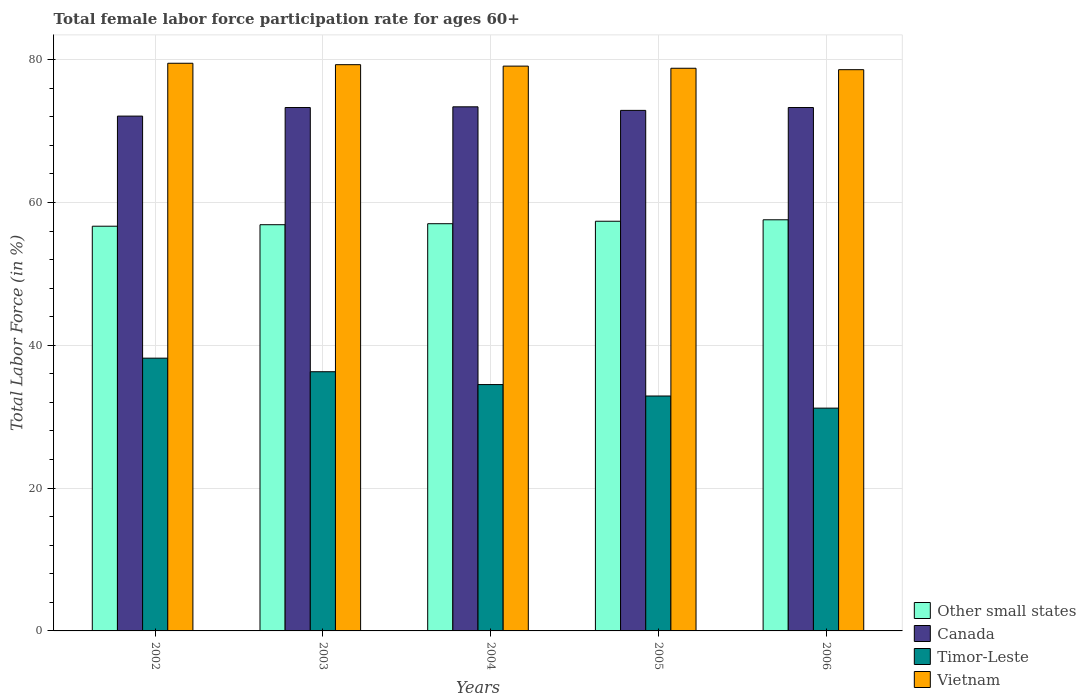How many groups of bars are there?
Your answer should be very brief. 5. Are the number of bars on each tick of the X-axis equal?
Offer a terse response. Yes. What is the female labor force participation rate in Timor-Leste in 2006?
Your answer should be very brief. 31.2. Across all years, what is the maximum female labor force participation rate in Canada?
Your answer should be compact. 73.4. Across all years, what is the minimum female labor force participation rate in Other small states?
Give a very brief answer. 56.68. In which year was the female labor force participation rate in Other small states minimum?
Provide a succinct answer. 2002. What is the total female labor force participation rate in Other small states in the graph?
Your response must be concise. 285.55. What is the difference between the female labor force participation rate in Timor-Leste in 2003 and that in 2006?
Keep it short and to the point. 5.1. What is the difference between the female labor force participation rate in Other small states in 2006 and the female labor force participation rate in Vietnam in 2004?
Provide a succinct answer. -21.52. What is the average female labor force participation rate in Vietnam per year?
Give a very brief answer. 79.06. In the year 2006, what is the difference between the female labor force participation rate in Vietnam and female labor force participation rate in Canada?
Provide a short and direct response. 5.3. In how many years, is the female labor force participation rate in Canada greater than 36 %?
Ensure brevity in your answer.  5. What is the ratio of the female labor force participation rate in Other small states in 2003 to that in 2005?
Provide a succinct answer. 0.99. Is the female labor force participation rate in Canada in 2005 less than that in 2006?
Offer a terse response. Yes. What is the difference between the highest and the second highest female labor force participation rate in Other small states?
Ensure brevity in your answer.  0.2. What is the difference between the highest and the lowest female labor force participation rate in Vietnam?
Provide a short and direct response. 0.9. In how many years, is the female labor force participation rate in Vietnam greater than the average female labor force participation rate in Vietnam taken over all years?
Ensure brevity in your answer.  3. Is it the case that in every year, the sum of the female labor force participation rate in Other small states and female labor force participation rate in Timor-Leste is greater than the sum of female labor force participation rate in Canada and female labor force participation rate in Vietnam?
Give a very brief answer. No. What does the 4th bar from the left in 2005 represents?
Keep it short and to the point. Vietnam. What does the 2nd bar from the right in 2006 represents?
Offer a terse response. Timor-Leste. Is it the case that in every year, the sum of the female labor force participation rate in Timor-Leste and female labor force participation rate in Vietnam is greater than the female labor force participation rate in Canada?
Your answer should be very brief. Yes. Are all the bars in the graph horizontal?
Your response must be concise. No. Does the graph contain any zero values?
Your response must be concise. No. How many legend labels are there?
Ensure brevity in your answer.  4. How are the legend labels stacked?
Make the answer very short. Vertical. What is the title of the graph?
Offer a very short reply. Total female labor force participation rate for ages 60+. Does "Oman" appear as one of the legend labels in the graph?
Your answer should be very brief. No. What is the label or title of the X-axis?
Offer a very short reply. Years. What is the Total Labor Force (in %) of Other small states in 2002?
Ensure brevity in your answer.  56.68. What is the Total Labor Force (in %) in Canada in 2002?
Offer a terse response. 72.1. What is the Total Labor Force (in %) of Timor-Leste in 2002?
Keep it short and to the point. 38.2. What is the Total Labor Force (in %) in Vietnam in 2002?
Your answer should be very brief. 79.5. What is the Total Labor Force (in %) in Other small states in 2003?
Offer a terse response. 56.89. What is the Total Labor Force (in %) of Canada in 2003?
Give a very brief answer. 73.3. What is the Total Labor Force (in %) of Timor-Leste in 2003?
Offer a terse response. 36.3. What is the Total Labor Force (in %) in Vietnam in 2003?
Provide a short and direct response. 79.3. What is the Total Labor Force (in %) in Other small states in 2004?
Your answer should be very brief. 57.03. What is the Total Labor Force (in %) in Canada in 2004?
Offer a terse response. 73.4. What is the Total Labor Force (in %) in Timor-Leste in 2004?
Offer a very short reply. 34.5. What is the Total Labor Force (in %) in Vietnam in 2004?
Make the answer very short. 79.1. What is the Total Labor Force (in %) of Other small states in 2005?
Provide a short and direct response. 57.37. What is the Total Labor Force (in %) of Canada in 2005?
Provide a succinct answer. 72.9. What is the Total Labor Force (in %) of Timor-Leste in 2005?
Offer a terse response. 32.9. What is the Total Labor Force (in %) in Vietnam in 2005?
Keep it short and to the point. 78.8. What is the Total Labor Force (in %) of Other small states in 2006?
Your response must be concise. 57.58. What is the Total Labor Force (in %) of Canada in 2006?
Offer a very short reply. 73.3. What is the Total Labor Force (in %) in Timor-Leste in 2006?
Offer a very short reply. 31.2. What is the Total Labor Force (in %) in Vietnam in 2006?
Provide a succinct answer. 78.6. Across all years, what is the maximum Total Labor Force (in %) in Other small states?
Offer a terse response. 57.58. Across all years, what is the maximum Total Labor Force (in %) in Canada?
Offer a very short reply. 73.4. Across all years, what is the maximum Total Labor Force (in %) of Timor-Leste?
Your answer should be compact. 38.2. Across all years, what is the maximum Total Labor Force (in %) of Vietnam?
Give a very brief answer. 79.5. Across all years, what is the minimum Total Labor Force (in %) in Other small states?
Your response must be concise. 56.68. Across all years, what is the minimum Total Labor Force (in %) in Canada?
Your answer should be compact. 72.1. Across all years, what is the minimum Total Labor Force (in %) in Timor-Leste?
Make the answer very short. 31.2. Across all years, what is the minimum Total Labor Force (in %) of Vietnam?
Offer a terse response. 78.6. What is the total Total Labor Force (in %) in Other small states in the graph?
Offer a terse response. 285.55. What is the total Total Labor Force (in %) of Canada in the graph?
Give a very brief answer. 365. What is the total Total Labor Force (in %) of Timor-Leste in the graph?
Keep it short and to the point. 173.1. What is the total Total Labor Force (in %) of Vietnam in the graph?
Give a very brief answer. 395.3. What is the difference between the Total Labor Force (in %) of Other small states in 2002 and that in 2003?
Give a very brief answer. -0.21. What is the difference between the Total Labor Force (in %) in Timor-Leste in 2002 and that in 2003?
Offer a very short reply. 1.9. What is the difference between the Total Labor Force (in %) of Vietnam in 2002 and that in 2003?
Your response must be concise. 0.2. What is the difference between the Total Labor Force (in %) in Other small states in 2002 and that in 2004?
Provide a succinct answer. -0.35. What is the difference between the Total Labor Force (in %) in Canada in 2002 and that in 2004?
Keep it short and to the point. -1.3. What is the difference between the Total Labor Force (in %) in Other small states in 2002 and that in 2005?
Provide a short and direct response. -0.69. What is the difference between the Total Labor Force (in %) in Other small states in 2002 and that in 2006?
Keep it short and to the point. -0.9. What is the difference between the Total Labor Force (in %) in Other small states in 2003 and that in 2004?
Offer a terse response. -0.14. What is the difference between the Total Labor Force (in %) in Canada in 2003 and that in 2004?
Your answer should be very brief. -0.1. What is the difference between the Total Labor Force (in %) of Timor-Leste in 2003 and that in 2004?
Offer a very short reply. 1.8. What is the difference between the Total Labor Force (in %) of Other small states in 2003 and that in 2005?
Your answer should be compact. -0.49. What is the difference between the Total Labor Force (in %) in Canada in 2003 and that in 2005?
Provide a succinct answer. 0.4. What is the difference between the Total Labor Force (in %) in Vietnam in 2003 and that in 2005?
Ensure brevity in your answer.  0.5. What is the difference between the Total Labor Force (in %) in Other small states in 2003 and that in 2006?
Ensure brevity in your answer.  -0.69. What is the difference between the Total Labor Force (in %) of Canada in 2003 and that in 2006?
Give a very brief answer. 0. What is the difference between the Total Labor Force (in %) of Timor-Leste in 2003 and that in 2006?
Your answer should be compact. 5.1. What is the difference between the Total Labor Force (in %) of Vietnam in 2003 and that in 2006?
Keep it short and to the point. 0.7. What is the difference between the Total Labor Force (in %) in Other small states in 2004 and that in 2005?
Offer a terse response. -0.35. What is the difference between the Total Labor Force (in %) in Canada in 2004 and that in 2005?
Ensure brevity in your answer.  0.5. What is the difference between the Total Labor Force (in %) in Timor-Leste in 2004 and that in 2005?
Your answer should be compact. 1.6. What is the difference between the Total Labor Force (in %) in Other small states in 2004 and that in 2006?
Offer a very short reply. -0.55. What is the difference between the Total Labor Force (in %) in Canada in 2004 and that in 2006?
Provide a succinct answer. 0.1. What is the difference between the Total Labor Force (in %) in Other small states in 2005 and that in 2006?
Provide a short and direct response. -0.2. What is the difference between the Total Labor Force (in %) of Canada in 2005 and that in 2006?
Your answer should be very brief. -0.4. What is the difference between the Total Labor Force (in %) in Timor-Leste in 2005 and that in 2006?
Offer a terse response. 1.7. What is the difference between the Total Labor Force (in %) of Other small states in 2002 and the Total Labor Force (in %) of Canada in 2003?
Offer a terse response. -16.62. What is the difference between the Total Labor Force (in %) in Other small states in 2002 and the Total Labor Force (in %) in Timor-Leste in 2003?
Provide a succinct answer. 20.38. What is the difference between the Total Labor Force (in %) in Other small states in 2002 and the Total Labor Force (in %) in Vietnam in 2003?
Offer a very short reply. -22.62. What is the difference between the Total Labor Force (in %) in Canada in 2002 and the Total Labor Force (in %) in Timor-Leste in 2003?
Your response must be concise. 35.8. What is the difference between the Total Labor Force (in %) of Canada in 2002 and the Total Labor Force (in %) of Vietnam in 2003?
Offer a terse response. -7.2. What is the difference between the Total Labor Force (in %) in Timor-Leste in 2002 and the Total Labor Force (in %) in Vietnam in 2003?
Give a very brief answer. -41.1. What is the difference between the Total Labor Force (in %) of Other small states in 2002 and the Total Labor Force (in %) of Canada in 2004?
Give a very brief answer. -16.72. What is the difference between the Total Labor Force (in %) of Other small states in 2002 and the Total Labor Force (in %) of Timor-Leste in 2004?
Your response must be concise. 22.18. What is the difference between the Total Labor Force (in %) in Other small states in 2002 and the Total Labor Force (in %) in Vietnam in 2004?
Your response must be concise. -22.42. What is the difference between the Total Labor Force (in %) in Canada in 2002 and the Total Labor Force (in %) in Timor-Leste in 2004?
Your response must be concise. 37.6. What is the difference between the Total Labor Force (in %) in Canada in 2002 and the Total Labor Force (in %) in Vietnam in 2004?
Keep it short and to the point. -7. What is the difference between the Total Labor Force (in %) of Timor-Leste in 2002 and the Total Labor Force (in %) of Vietnam in 2004?
Keep it short and to the point. -40.9. What is the difference between the Total Labor Force (in %) of Other small states in 2002 and the Total Labor Force (in %) of Canada in 2005?
Your answer should be compact. -16.22. What is the difference between the Total Labor Force (in %) in Other small states in 2002 and the Total Labor Force (in %) in Timor-Leste in 2005?
Give a very brief answer. 23.78. What is the difference between the Total Labor Force (in %) of Other small states in 2002 and the Total Labor Force (in %) of Vietnam in 2005?
Give a very brief answer. -22.12. What is the difference between the Total Labor Force (in %) in Canada in 2002 and the Total Labor Force (in %) in Timor-Leste in 2005?
Make the answer very short. 39.2. What is the difference between the Total Labor Force (in %) of Canada in 2002 and the Total Labor Force (in %) of Vietnam in 2005?
Give a very brief answer. -6.7. What is the difference between the Total Labor Force (in %) of Timor-Leste in 2002 and the Total Labor Force (in %) of Vietnam in 2005?
Provide a succinct answer. -40.6. What is the difference between the Total Labor Force (in %) in Other small states in 2002 and the Total Labor Force (in %) in Canada in 2006?
Keep it short and to the point. -16.62. What is the difference between the Total Labor Force (in %) in Other small states in 2002 and the Total Labor Force (in %) in Timor-Leste in 2006?
Give a very brief answer. 25.48. What is the difference between the Total Labor Force (in %) of Other small states in 2002 and the Total Labor Force (in %) of Vietnam in 2006?
Provide a succinct answer. -21.92. What is the difference between the Total Labor Force (in %) in Canada in 2002 and the Total Labor Force (in %) in Timor-Leste in 2006?
Make the answer very short. 40.9. What is the difference between the Total Labor Force (in %) of Timor-Leste in 2002 and the Total Labor Force (in %) of Vietnam in 2006?
Keep it short and to the point. -40.4. What is the difference between the Total Labor Force (in %) in Other small states in 2003 and the Total Labor Force (in %) in Canada in 2004?
Keep it short and to the point. -16.51. What is the difference between the Total Labor Force (in %) in Other small states in 2003 and the Total Labor Force (in %) in Timor-Leste in 2004?
Give a very brief answer. 22.39. What is the difference between the Total Labor Force (in %) in Other small states in 2003 and the Total Labor Force (in %) in Vietnam in 2004?
Your response must be concise. -22.21. What is the difference between the Total Labor Force (in %) in Canada in 2003 and the Total Labor Force (in %) in Timor-Leste in 2004?
Your answer should be very brief. 38.8. What is the difference between the Total Labor Force (in %) of Timor-Leste in 2003 and the Total Labor Force (in %) of Vietnam in 2004?
Ensure brevity in your answer.  -42.8. What is the difference between the Total Labor Force (in %) in Other small states in 2003 and the Total Labor Force (in %) in Canada in 2005?
Your answer should be compact. -16.01. What is the difference between the Total Labor Force (in %) in Other small states in 2003 and the Total Labor Force (in %) in Timor-Leste in 2005?
Give a very brief answer. 23.99. What is the difference between the Total Labor Force (in %) in Other small states in 2003 and the Total Labor Force (in %) in Vietnam in 2005?
Keep it short and to the point. -21.91. What is the difference between the Total Labor Force (in %) in Canada in 2003 and the Total Labor Force (in %) in Timor-Leste in 2005?
Your response must be concise. 40.4. What is the difference between the Total Labor Force (in %) of Canada in 2003 and the Total Labor Force (in %) of Vietnam in 2005?
Give a very brief answer. -5.5. What is the difference between the Total Labor Force (in %) in Timor-Leste in 2003 and the Total Labor Force (in %) in Vietnam in 2005?
Ensure brevity in your answer.  -42.5. What is the difference between the Total Labor Force (in %) in Other small states in 2003 and the Total Labor Force (in %) in Canada in 2006?
Provide a succinct answer. -16.41. What is the difference between the Total Labor Force (in %) of Other small states in 2003 and the Total Labor Force (in %) of Timor-Leste in 2006?
Ensure brevity in your answer.  25.69. What is the difference between the Total Labor Force (in %) of Other small states in 2003 and the Total Labor Force (in %) of Vietnam in 2006?
Your answer should be very brief. -21.71. What is the difference between the Total Labor Force (in %) of Canada in 2003 and the Total Labor Force (in %) of Timor-Leste in 2006?
Provide a succinct answer. 42.1. What is the difference between the Total Labor Force (in %) in Timor-Leste in 2003 and the Total Labor Force (in %) in Vietnam in 2006?
Offer a very short reply. -42.3. What is the difference between the Total Labor Force (in %) of Other small states in 2004 and the Total Labor Force (in %) of Canada in 2005?
Your answer should be very brief. -15.87. What is the difference between the Total Labor Force (in %) of Other small states in 2004 and the Total Labor Force (in %) of Timor-Leste in 2005?
Provide a short and direct response. 24.13. What is the difference between the Total Labor Force (in %) of Other small states in 2004 and the Total Labor Force (in %) of Vietnam in 2005?
Keep it short and to the point. -21.77. What is the difference between the Total Labor Force (in %) of Canada in 2004 and the Total Labor Force (in %) of Timor-Leste in 2005?
Keep it short and to the point. 40.5. What is the difference between the Total Labor Force (in %) in Timor-Leste in 2004 and the Total Labor Force (in %) in Vietnam in 2005?
Offer a very short reply. -44.3. What is the difference between the Total Labor Force (in %) of Other small states in 2004 and the Total Labor Force (in %) of Canada in 2006?
Make the answer very short. -16.27. What is the difference between the Total Labor Force (in %) in Other small states in 2004 and the Total Labor Force (in %) in Timor-Leste in 2006?
Provide a short and direct response. 25.83. What is the difference between the Total Labor Force (in %) in Other small states in 2004 and the Total Labor Force (in %) in Vietnam in 2006?
Give a very brief answer. -21.57. What is the difference between the Total Labor Force (in %) of Canada in 2004 and the Total Labor Force (in %) of Timor-Leste in 2006?
Give a very brief answer. 42.2. What is the difference between the Total Labor Force (in %) in Timor-Leste in 2004 and the Total Labor Force (in %) in Vietnam in 2006?
Make the answer very short. -44.1. What is the difference between the Total Labor Force (in %) of Other small states in 2005 and the Total Labor Force (in %) of Canada in 2006?
Your response must be concise. -15.93. What is the difference between the Total Labor Force (in %) in Other small states in 2005 and the Total Labor Force (in %) in Timor-Leste in 2006?
Provide a succinct answer. 26.17. What is the difference between the Total Labor Force (in %) of Other small states in 2005 and the Total Labor Force (in %) of Vietnam in 2006?
Provide a succinct answer. -21.23. What is the difference between the Total Labor Force (in %) of Canada in 2005 and the Total Labor Force (in %) of Timor-Leste in 2006?
Your response must be concise. 41.7. What is the difference between the Total Labor Force (in %) of Canada in 2005 and the Total Labor Force (in %) of Vietnam in 2006?
Keep it short and to the point. -5.7. What is the difference between the Total Labor Force (in %) in Timor-Leste in 2005 and the Total Labor Force (in %) in Vietnam in 2006?
Provide a succinct answer. -45.7. What is the average Total Labor Force (in %) in Other small states per year?
Offer a very short reply. 57.11. What is the average Total Labor Force (in %) of Canada per year?
Your answer should be compact. 73. What is the average Total Labor Force (in %) of Timor-Leste per year?
Your answer should be very brief. 34.62. What is the average Total Labor Force (in %) of Vietnam per year?
Keep it short and to the point. 79.06. In the year 2002, what is the difference between the Total Labor Force (in %) in Other small states and Total Labor Force (in %) in Canada?
Offer a terse response. -15.42. In the year 2002, what is the difference between the Total Labor Force (in %) in Other small states and Total Labor Force (in %) in Timor-Leste?
Offer a very short reply. 18.48. In the year 2002, what is the difference between the Total Labor Force (in %) in Other small states and Total Labor Force (in %) in Vietnam?
Give a very brief answer. -22.82. In the year 2002, what is the difference between the Total Labor Force (in %) in Canada and Total Labor Force (in %) in Timor-Leste?
Ensure brevity in your answer.  33.9. In the year 2002, what is the difference between the Total Labor Force (in %) of Timor-Leste and Total Labor Force (in %) of Vietnam?
Give a very brief answer. -41.3. In the year 2003, what is the difference between the Total Labor Force (in %) in Other small states and Total Labor Force (in %) in Canada?
Your answer should be compact. -16.41. In the year 2003, what is the difference between the Total Labor Force (in %) of Other small states and Total Labor Force (in %) of Timor-Leste?
Provide a succinct answer. 20.59. In the year 2003, what is the difference between the Total Labor Force (in %) of Other small states and Total Labor Force (in %) of Vietnam?
Ensure brevity in your answer.  -22.41. In the year 2003, what is the difference between the Total Labor Force (in %) in Timor-Leste and Total Labor Force (in %) in Vietnam?
Ensure brevity in your answer.  -43. In the year 2004, what is the difference between the Total Labor Force (in %) in Other small states and Total Labor Force (in %) in Canada?
Your response must be concise. -16.37. In the year 2004, what is the difference between the Total Labor Force (in %) of Other small states and Total Labor Force (in %) of Timor-Leste?
Ensure brevity in your answer.  22.53. In the year 2004, what is the difference between the Total Labor Force (in %) in Other small states and Total Labor Force (in %) in Vietnam?
Keep it short and to the point. -22.07. In the year 2004, what is the difference between the Total Labor Force (in %) of Canada and Total Labor Force (in %) of Timor-Leste?
Offer a very short reply. 38.9. In the year 2004, what is the difference between the Total Labor Force (in %) in Timor-Leste and Total Labor Force (in %) in Vietnam?
Your answer should be compact. -44.6. In the year 2005, what is the difference between the Total Labor Force (in %) in Other small states and Total Labor Force (in %) in Canada?
Offer a terse response. -15.53. In the year 2005, what is the difference between the Total Labor Force (in %) in Other small states and Total Labor Force (in %) in Timor-Leste?
Your answer should be compact. 24.47. In the year 2005, what is the difference between the Total Labor Force (in %) in Other small states and Total Labor Force (in %) in Vietnam?
Your answer should be compact. -21.43. In the year 2005, what is the difference between the Total Labor Force (in %) in Canada and Total Labor Force (in %) in Timor-Leste?
Provide a succinct answer. 40. In the year 2005, what is the difference between the Total Labor Force (in %) of Timor-Leste and Total Labor Force (in %) of Vietnam?
Offer a very short reply. -45.9. In the year 2006, what is the difference between the Total Labor Force (in %) of Other small states and Total Labor Force (in %) of Canada?
Offer a terse response. -15.72. In the year 2006, what is the difference between the Total Labor Force (in %) of Other small states and Total Labor Force (in %) of Timor-Leste?
Offer a terse response. 26.38. In the year 2006, what is the difference between the Total Labor Force (in %) of Other small states and Total Labor Force (in %) of Vietnam?
Give a very brief answer. -21.02. In the year 2006, what is the difference between the Total Labor Force (in %) in Canada and Total Labor Force (in %) in Timor-Leste?
Offer a terse response. 42.1. In the year 2006, what is the difference between the Total Labor Force (in %) of Canada and Total Labor Force (in %) of Vietnam?
Your answer should be very brief. -5.3. In the year 2006, what is the difference between the Total Labor Force (in %) of Timor-Leste and Total Labor Force (in %) of Vietnam?
Keep it short and to the point. -47.4. What is the ratio of the Total Labor Force (in %) of Canada in 2002 to that in 2003?
Give a very brief answer. 0.98. What is the ratio of the Total Labor Force (in %) of Timor-Leste in 2002 to that in 2003?
Ensure brevity in your answer.  1.05. What is the ratio of the Total Labor Force (in %) of Vietnam in 2002 to that in 2003?
Provide a short and direct response. 1. What is the ratio of the Total Labor Force (in %) in Canada in 2002 to that in 2004?
Your answer should be compact. 0.98. What is the ratio of the Total Labor Force (in %) in Timor-Leste in 2002 to that in 2004?
Offer a terse response. 1.11. What is the ratio of the Total Labor Force (in %) in Vietnam in 2002 to that in 2004?
Your response must be concise. 1.01. What is the ratio of the Total Labor Force (in %) of Other small states in 2002 to that in 2005?
Provide a succinct answer. 0.99. What is the ratio of the Total Labor Force (in %) in Timor-Leste in 2002 to that in 2005?
Your response must be concise. 1.16. What is the ratio of the Total Labor Force (in %) of Vietnam in 2002 to that in 2005?
Give a very brief answer. 1.01. What is the ratio of the Total Labor Force (in %) in Other small states in 2002 to that in 2006?
Offer a very short reply. 0.98. What is the ratio of the Total Labor Force (in %) in Canada in 2002 to that in 2006?
Your answer should be very brief. 0.98. What is the ratio of the Total Labor Force (in %) in Timor-Leste in 2002 to that in 2006?
Keep it short and to the point. 1.22. What is the ratio of the Total Labor Force (in %) in Vietnam in 2002 to that in 2006?
Offer a terse response. 1.01. What is the ratio of the Total Labor Force (in %) of Other small states in 2003 to that in 2004?
Keep it short and to the point. 1. What is the ratio of the Total Labor Force (in %) of Canada in 2003 to that in 2004?
Your answer should be compact. 1. What is the ratio of the Total Labor Force (in %) in Timor-Leste in 2003 to that in 2004?
Offer a very short reply. 1.05. What is the ratio of the Total Labor Force (in %) in Vietnam in 2003 to that in 2004?
Your answer should be very brief. 1. What is the ratio of the Total Labor Force (in %) in Canada in 2003 to that in 2005?
Provide a succinct answer. 1.01. What is the ratio of the Total Labor Force (in %) in Timor-Leste in 2003 to that in 2005?
Your response must be concise. 1.1. What is the ratio of the Total Labor Force (in %) in Vietnam in 2003 to that in 2005?
Provide a short and direct response. 1.01. What is the ratio of the Total Labor Force (in %) of Canada in 2003 to that in 2006?
Your answer should be compact. 1. What is the ratio of the Total Labor Force (in %) in Timor-Leste in 2003 to that in 2006?
Keep it short and to the point. 1.16. What is the ratio of the Total Labor Force (in %) in Vietnam in 2003 to that in 2006?
Provide a succinct answer. 1.01. What is the ratio of the Total Labor Force (in %) in Timor-Leste in 2004 to that in 2005?
Offer a very short reply. 1.05. What is the ratio of the Total Labor Force (in %) in Canada in 2004 to that in 2006?
Your response must be concise. 1. What is the ratio of the Total Labor Force (in %) in Timor-Leste in 2004 to that in 2006?
Give a very brief answer. 1.11. What is the ratio of the Total Labor Force (in %) in Vietnam in 2004 to that in 2006?
Your response must be concise. 1.01. What is the ratio of the Total Labor Force (in %) of Timor-Leste in 2005 to that in 2006?
Provide a short and direct response. 1.05. What is the ratio of the Total Labor Force (in %) in Vietnam in 2005 to that in 2006?
Provide a short and direct response. 1. What is the difference between the highest and the second highest Total Labor Force (in %) of Other small states?
Make the answer very short. 0.2. What is the difference between the highest and the second highest Total Labor Force (in %) of Canada?
Give a very brief answer. 0.1. What is the difference between the highest and the lowest Total Labor Force (in %) in Other small states?
Ensure brevity in your answer.  0.9. What is the difference between the highest and the lowest Total Labor Force (in %) in Timor-Leste?
Make the answer very short. 7. 